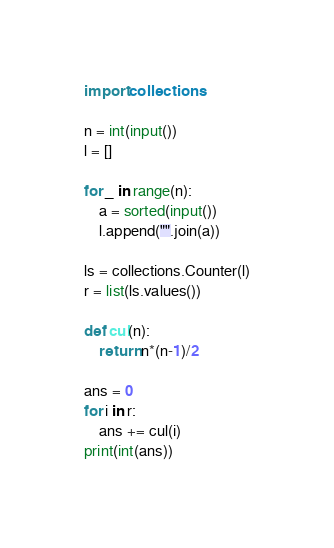<code> <loc_0><loc_0><loc_500><loc_500><_Python_>import collections

n = int(input())
l = []

for _ in range(n):
    a = sorted(input())
    l.append("".join(a))
    
ls = collections.Counter(l)
r = list(ls.values())

def cul(n):
    return n*(n-1)/2

ans = 0
for i in r:
    ans += cul(i)
print(int(ans))</code> 